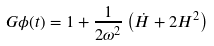Convert formula to latex. <formula><loc_0><loc_0><loc_500><loc_500>G \phi ( t ) = 1 + \frac { 1 } { 2 \omega ^ { 2 } } \left ( \dot { H } + 2 H ^ { 2 } \right )</formula> 